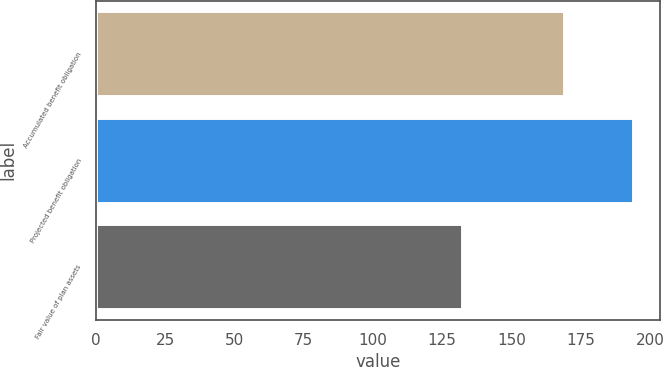Convert chart to OTSL. <chart><loc_0><loc_0><loc_500><loc_500><bar_chart><fcel>Accumulated benefit obligation<fcel>Projected benefit obligation<fcel>Fair value of plan assets<nl><fcel>169<fcel>194<fcel>132<nl></chart> 